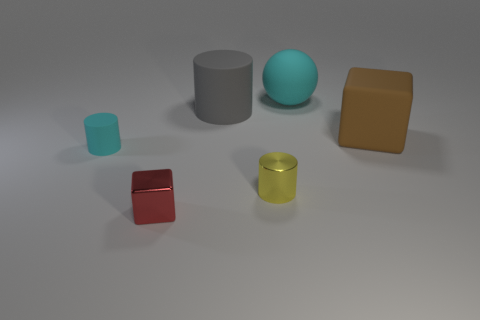Add 2 gray metallic cylinders. How many objects exist? 8 Subtract all blocks. How many objects are left? 4 Add 6 metallic blocks. How many metallic blocks are left? 7 Add 2 cyan spheres. How many cyan spheres exist? 3 Subtract 0 green balls. How many objects are left? 6 Subtract all big purple cylinders. Subtract all rubber cubes. How many objects are left? 5 